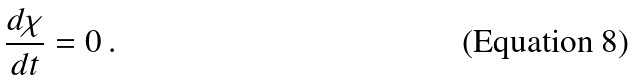<formula> <loc_0><loc_0><loc_500><loc_500>\frac { d \chi } { d t } = 0 \, .</formula> 